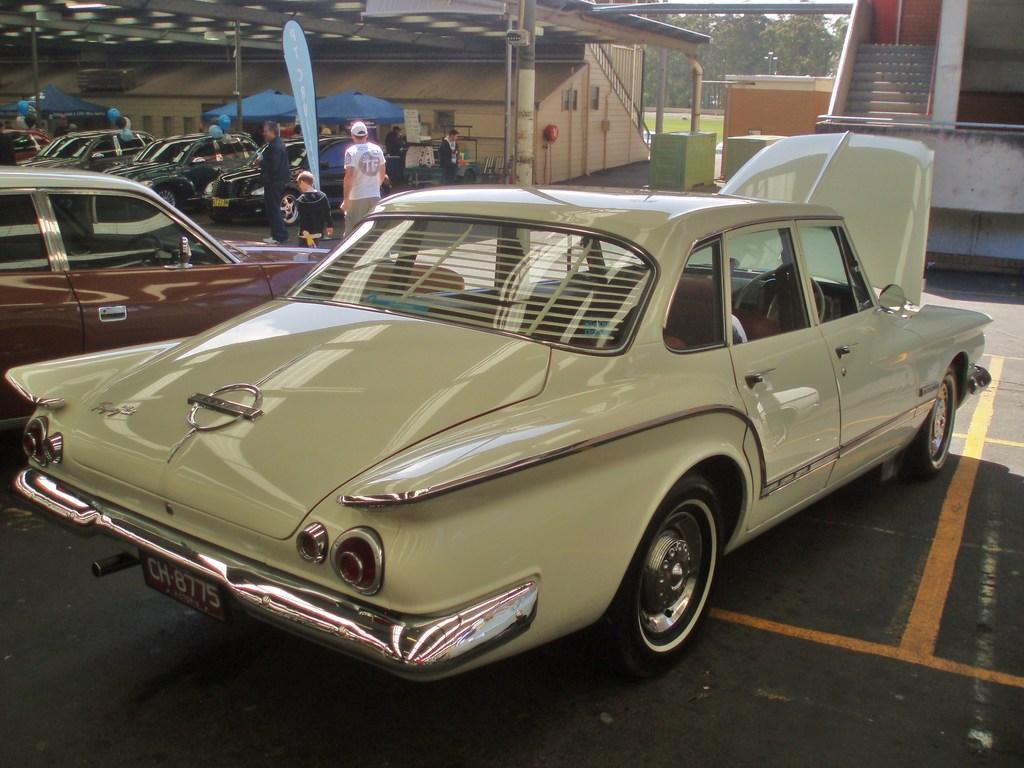How would you summarize this image in a sentence or two? There are many cars. Also there are few people. In the back there are buildings, tents and poles. Also there are steps for the building on the right side. In the background there are trees. 